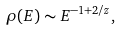<formula> <loc_0><loc_0><loc_500><loc_500>\rho ( E ) \sim E ^ { - 1 + 2 / z } ,</formula> 